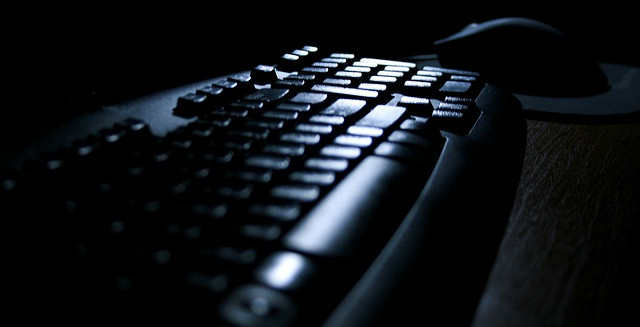Describe the objects in this image and their specific colors. I can see keyboard in black, lavender, navy, and blue tones and mouse in black, gray, blue, and darkblue tones in this image. 